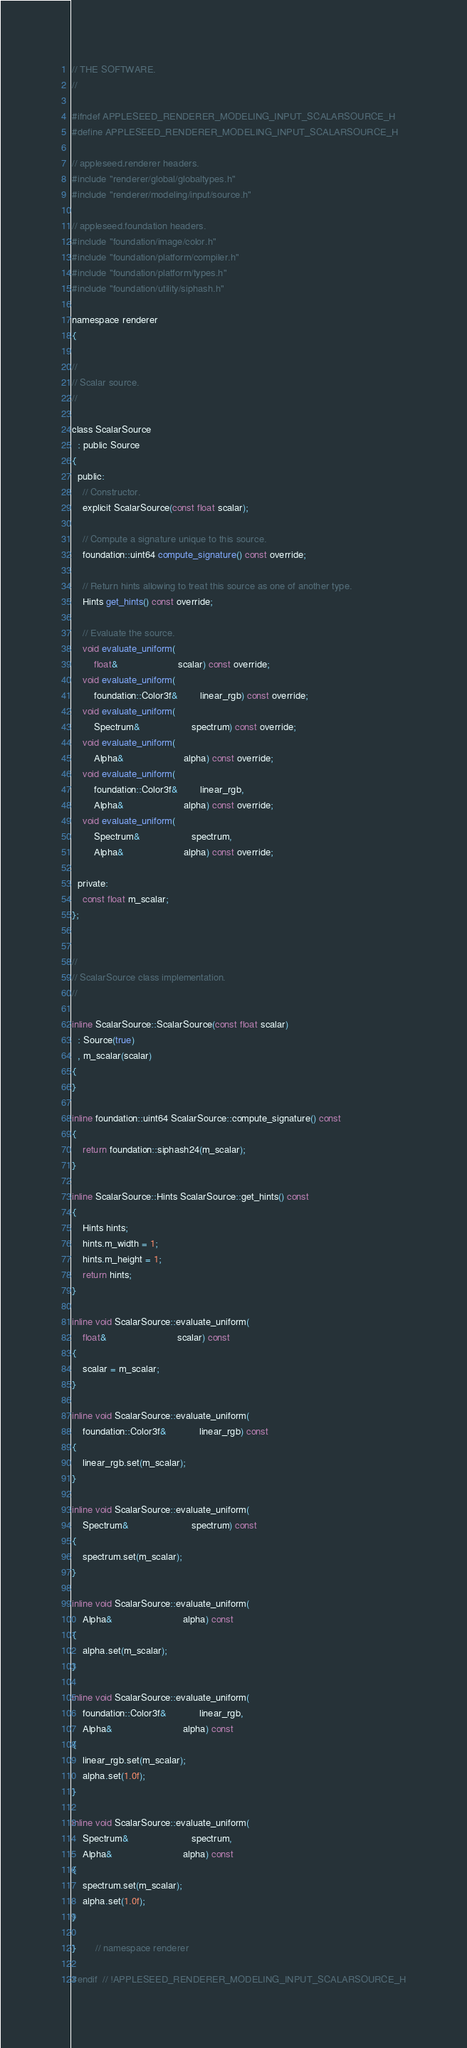<code> <loc_0><loc_0><loc_500><loc_500><_C_>// THE SOFTWARE.
//

#ifndef APPLESEED_RENDERER_MODELING_INPUT_SCALARSOURCE_H
#define APPLESEED_RENDERER_MODELING_INPUT_SCALARSOURCE_H

// appleseed.renderer headers.
#include "renderer/global/globaltypes.h"
#include "renderer/modeling/input/source.h"

// appleseed.foundation headers.
#include "foundation/image/color.h"
#include "foundation/platform/compiler.h"
#include "foundation/platform/types.h"
#include "foundation/utility/siphash.h"

namespace renderer
{

//
// Scalar source.
//

class ScalarSource
  : public Source
{
  public:
    // Constructor.
    explicit ScalarSource(const float scalar);

    // Compute a signature unique to this source.
    foundation::uint64 compute_signature() const override;

    // Return hints allowing to treat this source as one of another type.
    Hints get_hints() const override;

    // Evaluate the source.
    void evaluate_uniform(
        float&                      scalar) const override;
    void evaluate_uniform(
        foundation::Color3f&        linear_rgb) const override;
    void evaluate_uniform(
        Spectrum&                   spectrum) const override;
    void evaluate_uniform(
        Alpha&                      alpha) const override;
    void evaluate_uniform(
        foundation::Color3f&        linear_rgb,
        Alpha&                      alpha) const override;
    void evaluate_uniform(
        Spectrum&                   spectrum,
        Alpha&                      alpha) const override;

  private:
    const float m_scalar;
};


//
// ScalarSource class implementation.
//

inline ScalarSource::ScalarSource(const float scalar)
  : Source(true)
  , m_scalar(scalar)
{
}

inline foundation::uint64 ScalarSource::compute_signature() const
{
    return foundation::siphash24(m_scalar);
}

inline ScalarSource::Hints ScalarSource::get_hints() const
{
    Hints hints;
    hints.m_width = 1;
    hints.m_height = 1;
    return hints;
}

inline void ScalarSource::evaluate_uniform(
    float&                          scalar) const
{
    scalar = m_scalar;
}

inline void ScalarSource::evaluate_uniform(
    foundation::Color3f&            linear_rgb) const
{
    linear_rgb.set(m_scalar);
}

inline void ScalarSource::evaluate_uniform(
    Spectrum&                       spectrum) const
{
    spectrum.set(m_scalar);
}

inline void ScalarSource::evaluate_uniform(
    Alpha&                          alpha) const
{
    alpha.set(m_scalar);
}

inline void ScalarSource::evaluate_uniform(
    foundation::Color3f&            linear_rgb,
    Alpha&                          alpha) const
{
    linear_rgb.set(m_scalar);
    alpha.set(1.0f);
}

inline void ScalarSource::evaluate_uniform(
    Spectrum&                       spectrum,
    Alpha&                          alpha) const
{
    spectrum.set(m_scalar);
    alpha.set(1.0f);
}

}       // namespace renderer

#endif  // !APPLESEED_RENDERER_MODELING_INPUT_SCALARSOURCE_H
</code> 